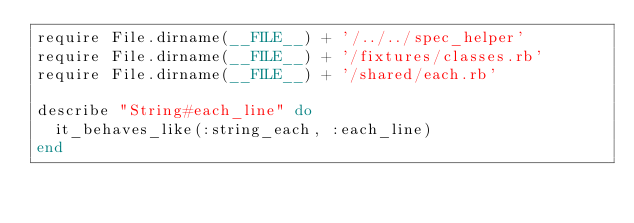Convert code to text. <code><loc_0><loc_0><loc_500><loc_500><_Ruby_>require File.dirname(__FILE__) + '/../../spec_helper'
require File.dirname(__FILE__) + '/fixtures/classes.rb'
require File.dirname(__FILE__) + '/shared/each.rb'

describe "String#each_line" do
  it_behaves_like(:string_each, :each_line)
end
</code> 